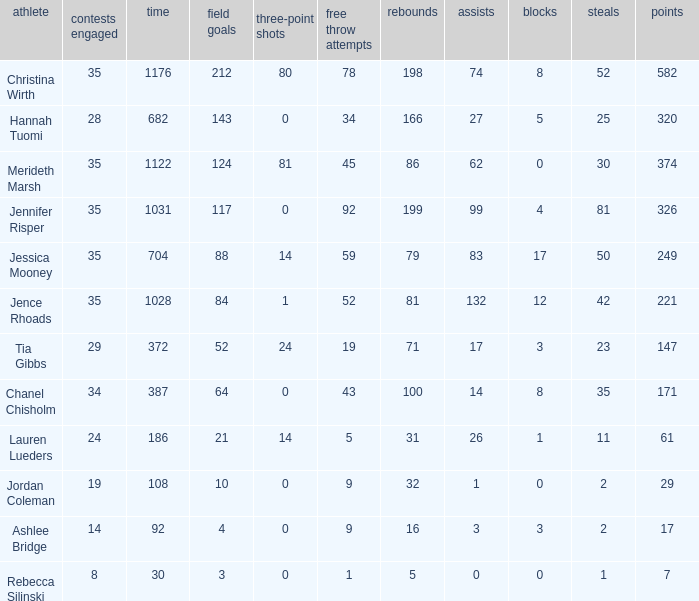How many blockings occured in the game with 198 rebounds? 8.0. 